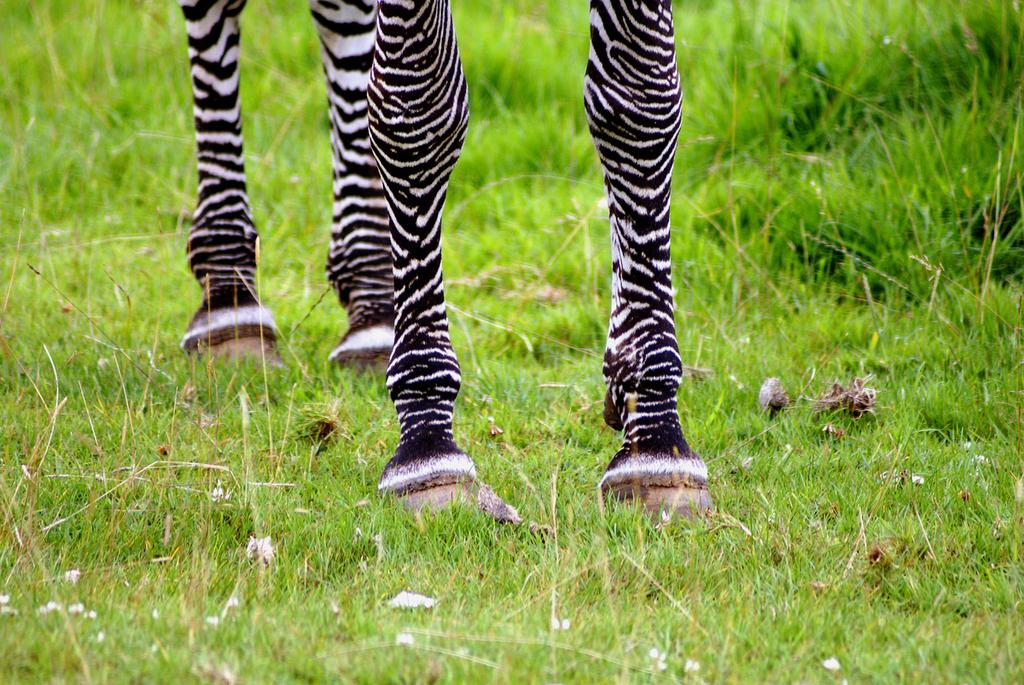What type of animal's legs are visible in the image? There are legs of a zebra in the image. What type of surface is at the bottom of the image? There is grass on the surface at the bottom of the image. What type of mitten is being used to reduce friction in the image? There is no mitten present in the image, and the concept of reducing friction is not applicable in this context. 